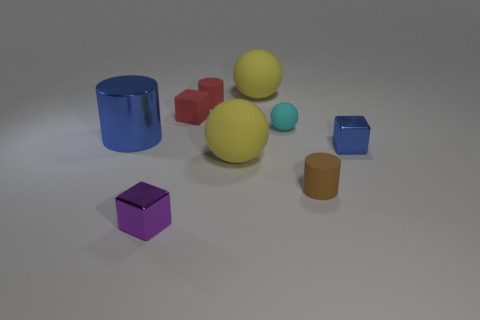Are there patterns or symmetry in the way objects are arranged? The objects are arranged without a discernible pattern or symmetry. They are placed at varying distances from one another, suggesting a random distribution. Could there be any symbolic meaning behind this arrangement? While there's no visible pattern, such an arrangement could symbolize chaos, diversity, or the random nature of elements in a space. 